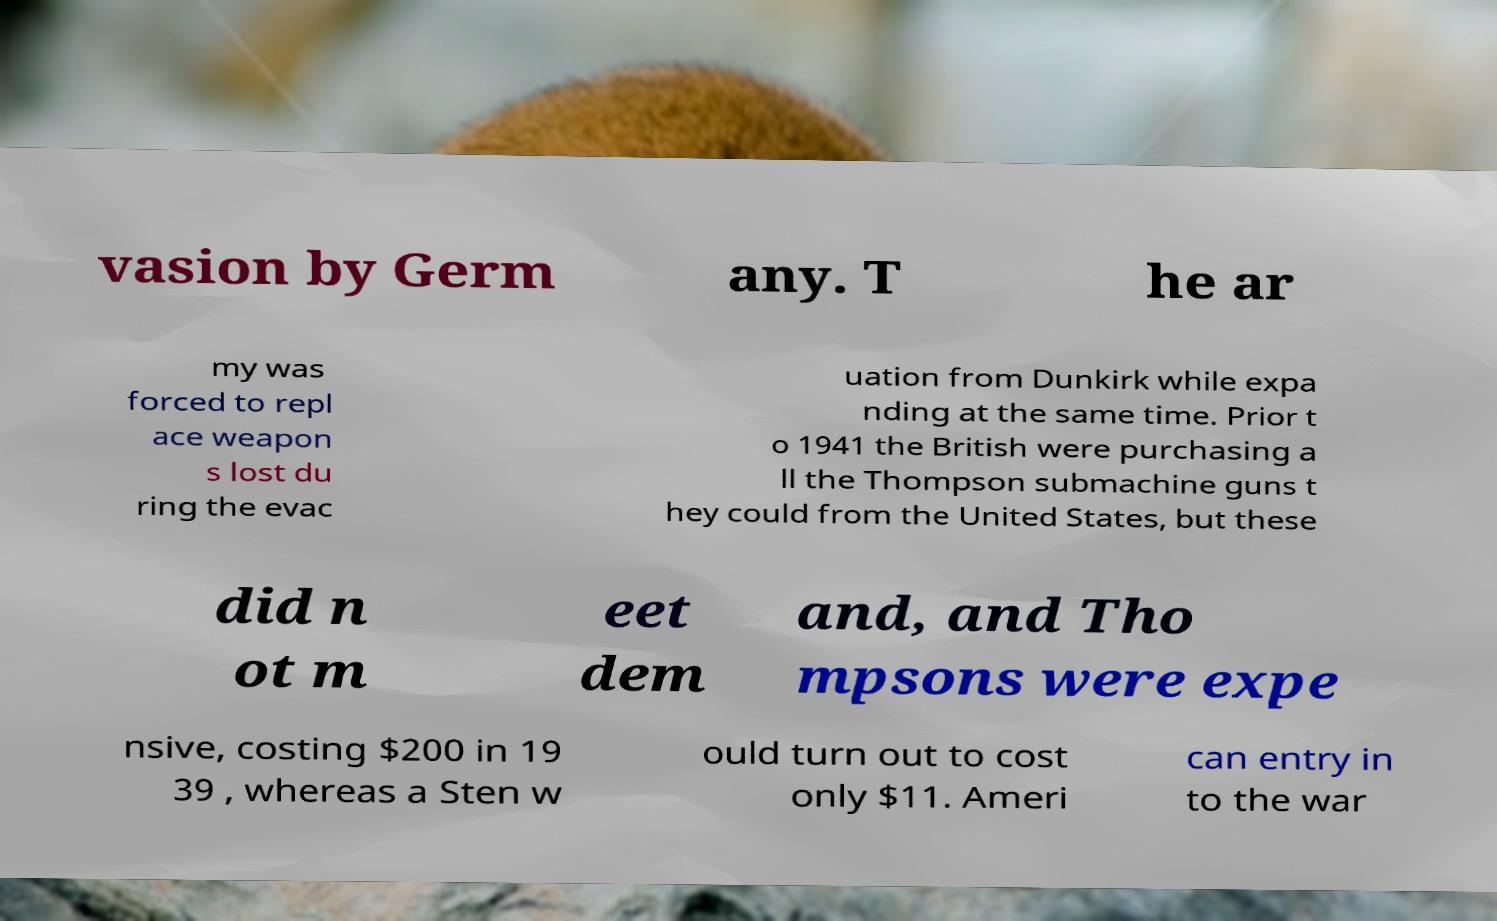For documentation purposes, I need the text within this image transcribed. Could you provide that? vasion by Germ any. T he ar my was forced to repl ace weapon s lost du ring the evac uation from Dunkirk while expa nding at the same time. Prior t o 1941 the British were purchasing a ll the Thompson submachine guns t hey could from the United States, but these did n ot m eet dem and, and Tho mpsons were expe nsive, costing $200 in 19 39 , whereas a Sten w ould turn out to cost only $11. Ameri can entry in to the war 